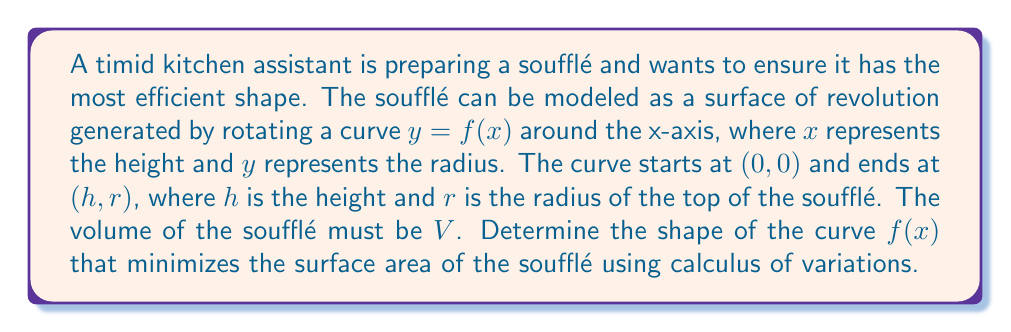Can you solve this math problem? Let's approach this problem step-by-step:

1) The surface area of a surface of revolution is given by:
   
   $$A = 2\pi \int_0^h y \sqrt{1 + (y')^2} dx$$

2) The volume constraint is:
   
   $$V = \pi \int_0^h y^2 dx$$

3) We need to minimize $A$ subject to the volume constraint. We can use the Euler-Lagrange equation with a Lagrange multiplier $\lambda$:
   
   $$F = 2\pi y \sqrt{1 + (y')^2} - \lambda \pi y^2$$

4) The Euler-Lagrange equation is:
   
   $$\frac{\partial F}{\partial y} - \frac{d}{dx}\left(\frac{\partial F}{\partial y'}\right) = 0$$

5) Calculating the partial derivatives:
   
   $$\frac{\partial F}{\partial y} = 2\pi \sqrt{1 + (y')^2} - 2\lambda \pi y$$
   
   $$\frac{\partial F}{\partial y'} = \frac{2\pi y y'}{\sqrt{1 + (y')^2}}$$

6) Substituting into the Euler-Lagrange equation:
   
   $$2\pi \sqrt{1 + (y')^2} - 2\lambda \pi y - \frac{d}{dx}\left(\frac{2\pi y y'}{\sqrt{1 + (y')^2}}\right) = 0$$

7) This differential equation can be simplified to:
   
   $$y'' = \frac{1 + (y')^2}{y} (1 - \lambda y)$$

8) The solution to this equation is:
   
   $$y = \frac{1}{\lambda} (1 - \cos(\lambda x + c))$$

   where $c$ is a constant of integration.

9) Applying the boundary conditions $y(0) = 0$ and $y(h) = r$, we get:
   
   $$c = 0$$ and $$r = \frac{1}{\lambda} (1 - \cos(\lambda h))$$

10) This curve is known as a catenary, which when rotated around the x-axis forms a surface called a catenoid.

Therefore, the shape that minimizes the surface area of the soufflé is a catenoid.
Answer: Catenoid with equation $y = \frac{1}{\lambda} (1 - \cos(\lambda x))$ 